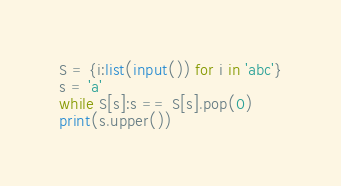Convert code to text. <code><loc_0><loc_0><loc_500><loc_500><_Python_>S = {i:list(input()) for i in 'abc'}
s = 'a'
while S[s]:s == S[s].pop(0)
print(s.upper())</code> 